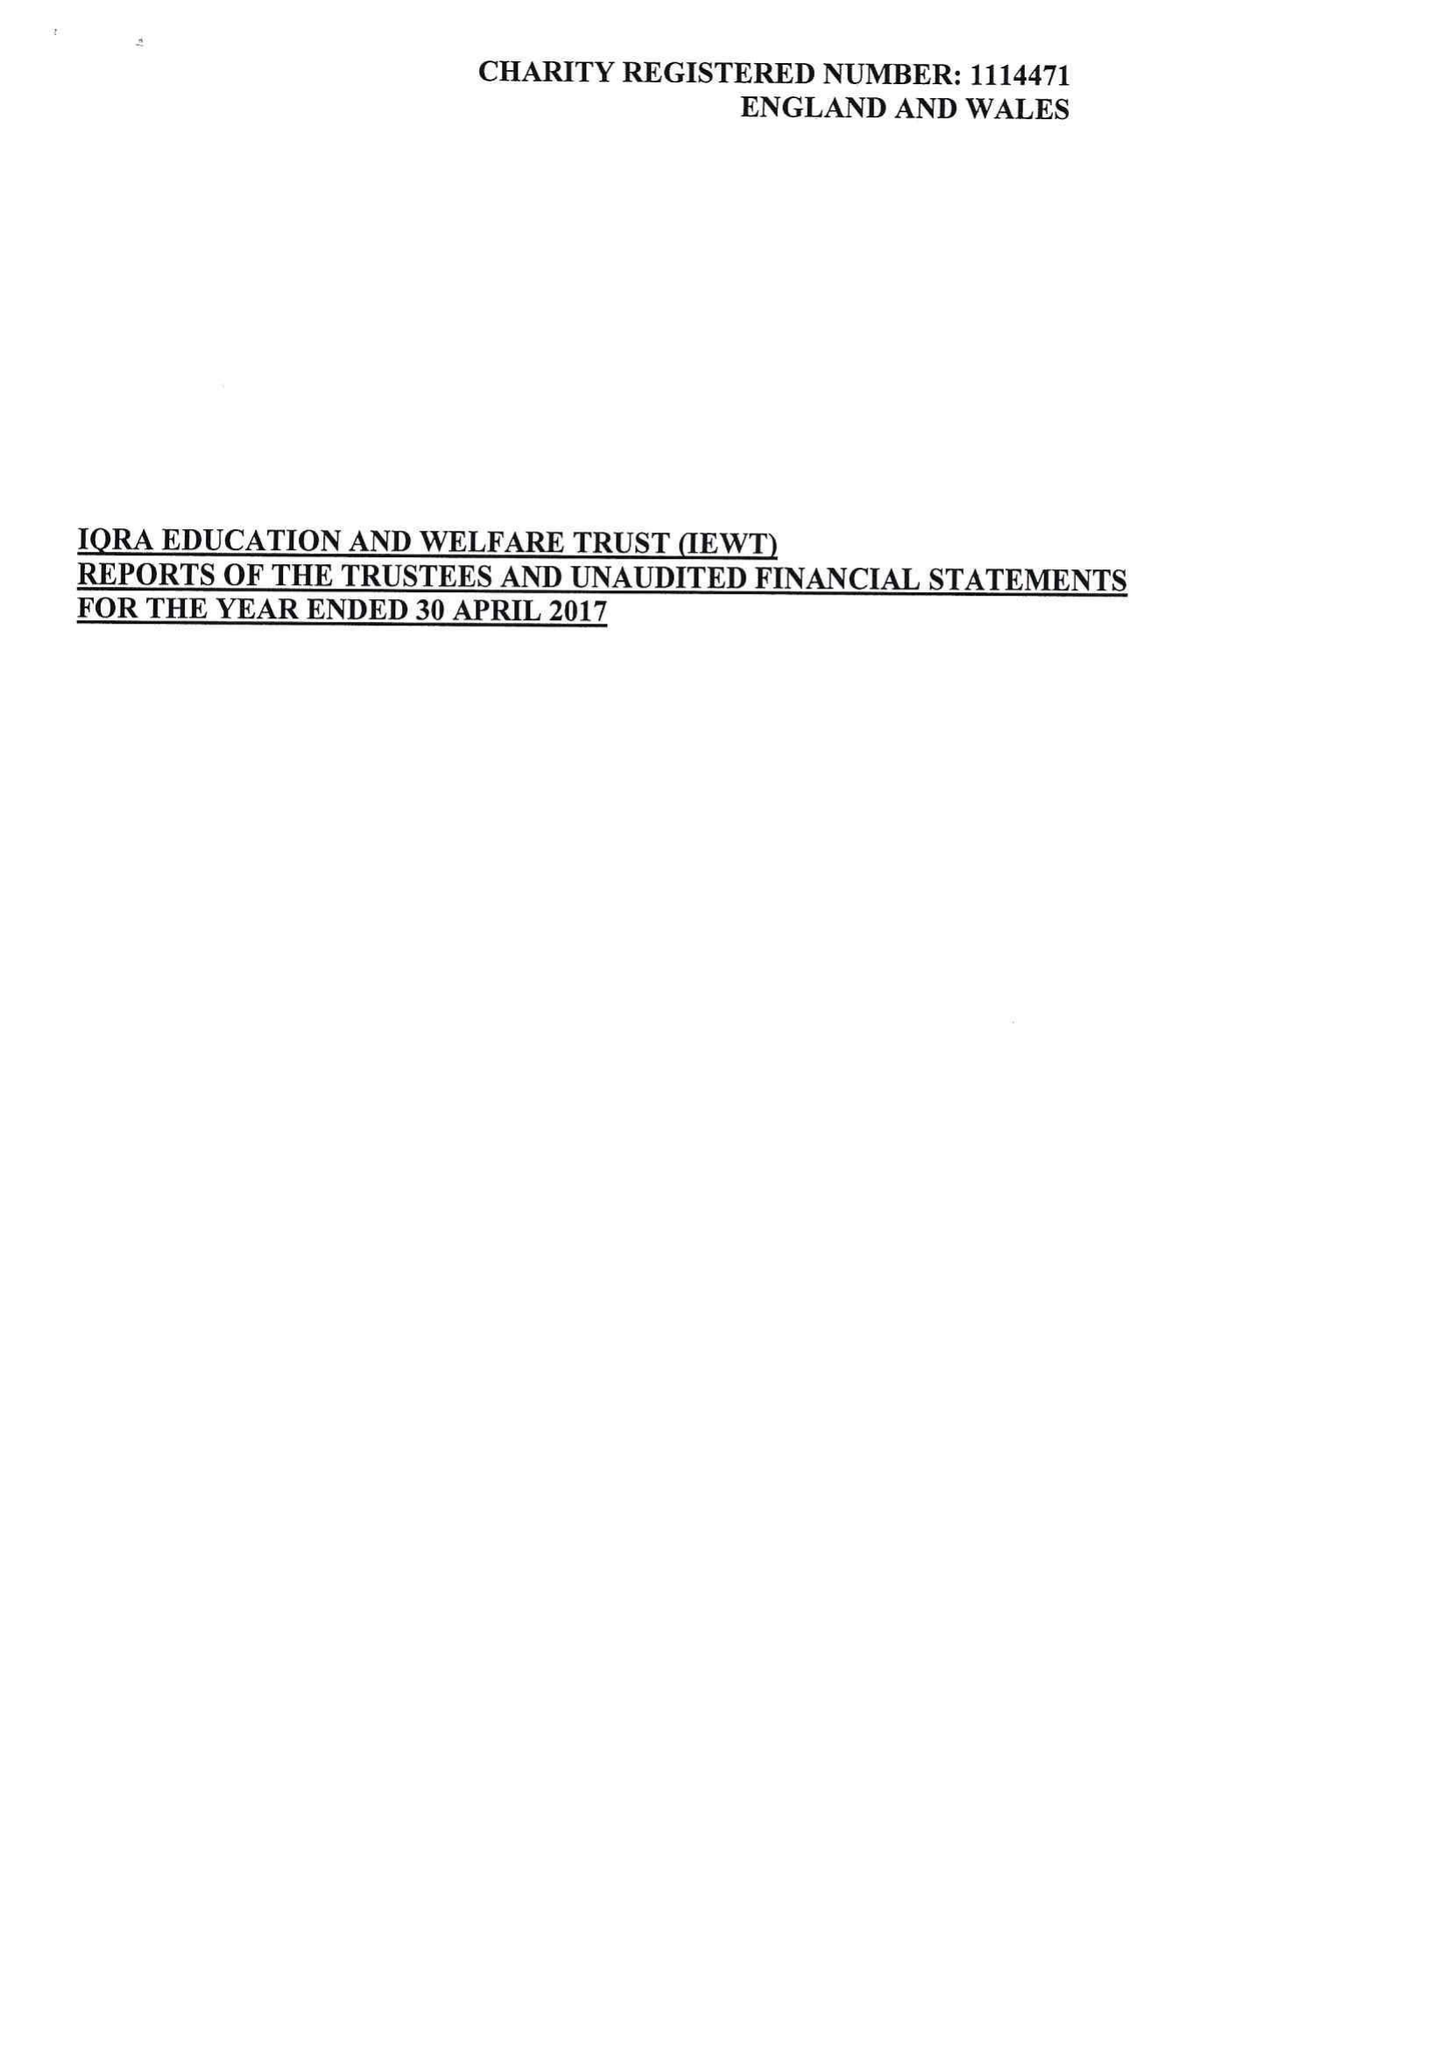What is the value for the charity_name?
Answer the question using a single word or phrase. Iqra Education and Welfare Trust (Iewt) 